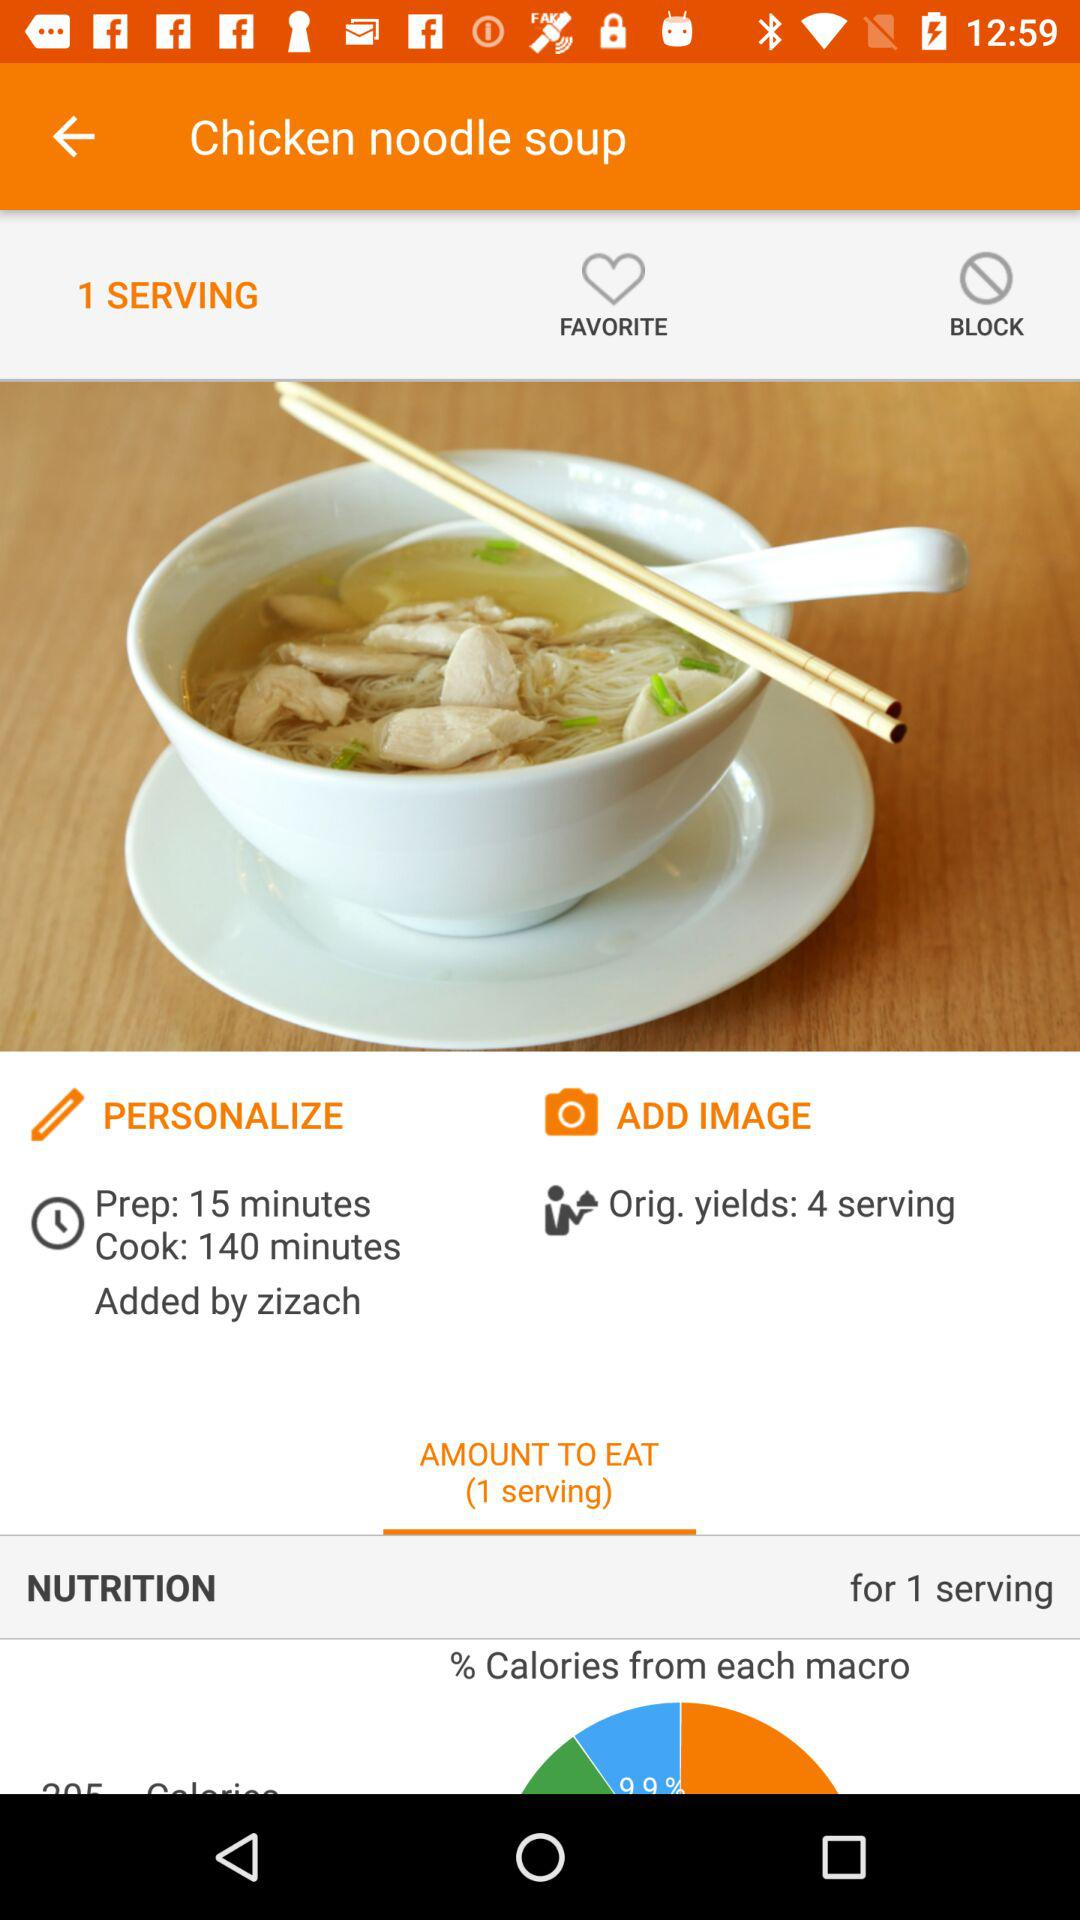What is the preparation time? The preparation time is 15 minutes. 